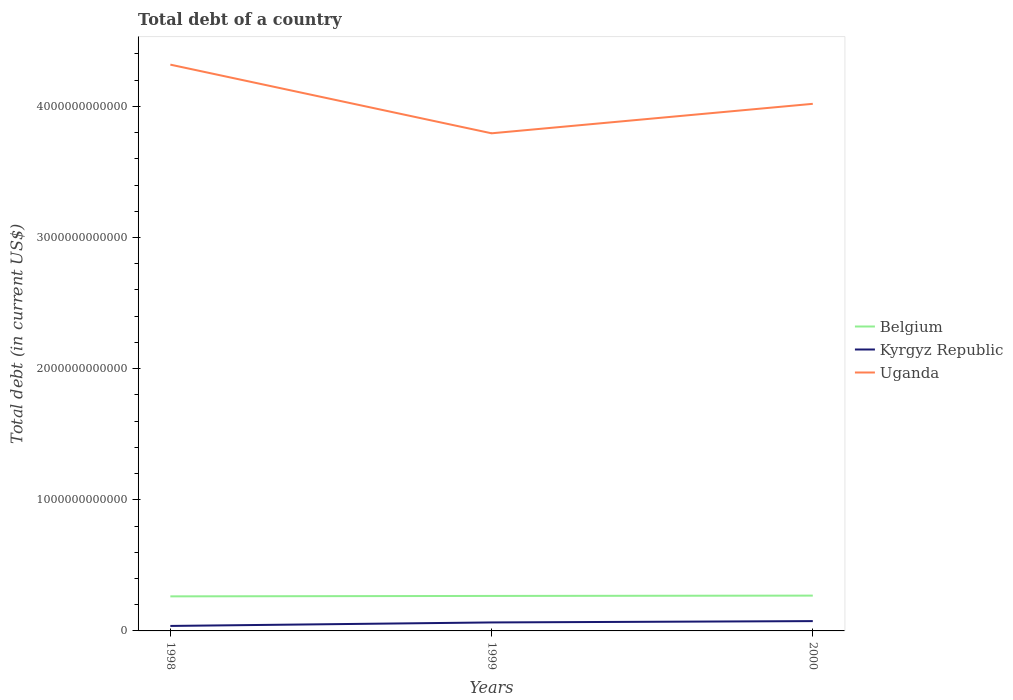How many different coloured lines are there?
Provide a succinct answer. 3. Does the line corresponding to Uganda intersect with the line corresponding to Belgium?
Your response must be concise. No. Across all years, what is the maximum debt in Kyrgyz Republic?
Offer a terse response. 3.80e+1. What is the total debt in Belgium in the graph?
Your answer should be compact. -5.65e+09. What is the difference between the highest and the second highest debt in Belgium?
Make the answer very short. 5.65e+09. What is the difference between the highest and the lowest debt in Uganda?
Offer a terse response. 1. Is the debt in Uganda strictly greater than the debt in Belgium over the years?
Your response must be concise. No. How many lines are there?
Make the answer very short. 3. How many years are there in the graph?
Keep it short and to the point. 3. What is the difference between two consecutive major ticks on the Y-axis?
Offer a terse response. 1.00e+12. Are the values on the major ticks of Y-axis written in scientific E-notation?
Offer a very short reply. No. Does the graph contain grids?
Your answer should be very brief. No. Where does the legend appear in the graph?
Your response must be concise. Center right. How are the legend labels stacked?
Make the answer very short. Vertical. What is the title of the graph?
Make the answer very short. Total debt of a country. Does "Israel" appear as one of the legend labels in the graph?
Your response must be concise. No. What is the label or title of the Y-axis?
Your answer should be very brief. Total debt (in current US$). What is the Total debt (in current US$) in Belgium in 1998?
Keep it short and to the point. 2.64e+11. What is the Total debt (in current US$) in Kyrgyz Republic in 1998?
Your answer should be compact. 3.80e+1. What is the Total debt (in current US$) of Uganda in 1998?
Give a very brief answer. 4.32e+12. What is the Total debt (in current US$) of Belgium in 1999?
Offer a very short reply. 2.67e+11. What is the Total debt (in current US$) of Kyrgyz Republic in 1999?
Keep it short and to the point. 6.47e+1. What is the Total debt (in current US$) in Uganda in 1999?
Make the answer very short. 3.79e+12. What is the Total debt (in current US$) in Belgium in 2000?
Offer a very short reply. 2.69e+11. What is the Total debt (in current US$) of Kyrgyz Republic in 2000?
Give a very brief answer. 7.49e+1. What is the Total debt (in current US$) of Uganda in 2000?
Offer a terse response. 4.02e+12. Across all years, what is the maximum Total debt (in current US$) of Belgium?
Offer a terse response. 2.69e+11. Across all years, what is the maximum Total debt (in current US$) of Kyrgyz Republic?
Offer a terse response. 7.49e+1. Across all years, what is the maximum Total debt (in current US$) of Uganda?
Provide a succinct answer. 4.32e+12. Across all years, what is the minimum Total debt (in current US$) of Belgium?
Provide a short and direct response. 2.64e+11. Across all years, what is the minimum Total debt (in current US$) in Kyrgyz Republic?
Provide a short and direct response. 3.80e+1. Across all years, what is the minimum Total debt (in current US$) of Uganda?
Offer a very short reply. 3.79e+12. What is the total Total debt (in current US$) in Belgium in the graph?
Make the answer very short. 8.00e+11. What is the total Total debt (in current US$) of Kyrgyz Republic in the graph?
Give a very brief answer. 1.78e+11. What is the total Total debt (in current US$) in Uganda in the graph?
Provide a succinct answer. 1.21e+13. What is the difference between the Total debt (in current US$) of Belgium in 1998 and that in 1999?
Your answer should be compact. -3.18e+09. What is the difference between the Total debt (in current US$) in Kyrgyz Republic in 1998 and that in 1999?
Your response must be concise. -2.67e+1. What is the difference between the Total debt (in current US$) in Uganda in 1998 and that in 1999?
Your answer should be very brief. 5.24e+11. What is the difference between the Total debt (in current US$) in Belgium in 1998 and that in 2000?
Your response must be concise. -5.65e+09. What is the difference between the Total debt (in current US$) of Kyrgyz Republic in 1998 and that in 2000?
Provide a short and direct response. -3.68e+1. What is the difference between the Total debt (in current US$) of Uganda in 1998 and that in 2000?
Keep it short and to the point. 2.99e+11. What is the difference between the Total debt (in current US$) in Belgium in 1999 and that in 2000?
Provide a succinct answer. -2.48e+09. What is the difference between the Total debt (in current US$) in Kyrgyz Republic in 1999 and that in 2000?
Provide a succinct answer. -1.02e+1. What is the difference between the Total debt (in current US$) of Uganda in 1999 and that in 2000?
Your response must be concise. -2.25e+11. What is the difference between the Total debt (in current US$) of Belgium in 1998 and the Total debt (in current US$) of Kyrgyz Republic in 1999?
Your answer should be very brief. 1.99e+11. What is the difference between the Total debt (in current US$) in Belgium in 1998 and the Total debt (in current US$) in Uganda in 1999?
Provide a short and direct response. -3.53e+12. What is the difference between the Total debt (in current US$) in Kyrgyz Republic in 1998 and the Total debt (in current US$) in Uganda in 1999?
Provide a short and direct response. -3.76e+12. What is the difference between the Total debt (in current US$) in Belgium in 1998 and the Total debt (in current US$) in Kyrgyz Republic in 2000?
Ensure brevity in your answer.  1.89e+11. What is the difference between the Total debt (in current US$) of Belgium in 1998 and the Total debt (in current US$) of Uganda in 2000?
Offer a terse response. -3.76e+12. What is the difference between the Total debt (in current US$) in Kyrgyz Republic in 1998 and the Total debt (in current US$) in Uganda in 2000?
Give a very brief answer. -3.98e+12. What is the difference between the Total debt (in current US$) in Belgium in 1999 and the Total debt (in current US$) in Kyrgyz Republic in 2000?
Give a very brief answer. 1.92e+11. What is the difference between the Total debt (in current US$) of Belgium in 1999 and the Total debt (in current US$) of Uganda in 2000?
Keep it short and to the point. -3.75e+12. What is the difference between the Total debt (in current US$) of Kyrgyz Republic in 1999 and the Total debt (in current US$) of Uganda in 2000?
Your answer should be compact. -3.96e+12. What is the average Total debt (in current US$) of Belgium per year?
Your response must be concise. 2.67e+11. What is the average Total debt (in current US$) in Kyrgyz Republic per year?
Make the answer very short. 5.92e+1. What is the average Total debt (in current US$) in Uganda per year?
Provide a succinct answer. 4.04e+12. In the year 1998, what is the difference between the Total debt (in current US$) in Belgium and Total debt (in current US$) in Kyrgyz Republic?
Offer a very short reply. 2.26e+11. In the year 1998, what is the difference between the Total debt (in current US$) in Belgium and Total debt (in current US$) in Uganda?
Your response must be concise. -4.05e+12. In the year 1998, what is the difference between the Total debt (in current US$) in Kyrgyz Republic and Total debt (in current US$) in Uganda?
Provide a succinct answer. -4.28e+12. In the year 1999, what is the difference between the Total debt (in current US$) in Belgium and Total debt (in current US$) in Kyrgyz Republic?
Ensure brevity in your answer.  2.02e+11. In the year 1999, what is the difference between the Total debt (in current US$) of Belgium and Total debt (in current US$) of Uganda?
Offer a terse response. -3.53e+12. In the year 1999, what is the difference between the Total debt (in current US$) in Kyrgyz Republic and Total debt (in current US$) in Uganda?
Provide a short and direct response. -3.73e+12. In the year 2000, what is the difference between the Total debt (in current US$) in Belgium and Total debt (in current US$) in Kyrgyz Republic?
Your response must be concise. 1.94e+11. In the year 2000, what is the difference between the Total debt (in current US$) of Belgium and Total debt (in current US$) of Uganda?
Provide a short and direct response. -3.75e+12. In the year 2000, what is the difference between the Total debt (in current US$) of Kyrgyz Republic and Total debt (in current US$) of Uganda?
Your answer should be compact. -3.94e+12. What is the ratio of the Total debt (in current US$) in Belgium in 1998 to that in 1999?
Keep it short and to the point. 0.99. What is the ratio of the Total debt (in current US$) in Kyrgyz Republic in 1998 to that in 1999?
Your answer should be very brief. 0.59. What is the ratio of the Total debt (in current US$) of Uganda in 1998 to that in 1999?
Your response must be concise. 1.14. What is the ratio of the Total debt (in current US$) in Belgium in 1998 to that in 2000?
Give a very brief answer. 0.98. What is the ratio of the Total debt (in current US$) in Kyrgyz Republic in 1998 to that in 2000?
Make the answer very short. 0.51. What is the ratio of the Total debt (in current US$) of Uganda in 1998 to that in 2000?
Ensure brevity in your answer.  1.07. What is the ratio of the Total debt (in current US$) of Belgium in 1999 to that in 2000?
Your answer should be very brief. 0.99. What is the ratio of the Total debt (in current US$) in Kyrgyz Republic in 1999 to that in 2000?
Provide a short and direct response. 0.86. What is the ratio of the Total debt (in current US$) in Uganda in 1999 to that in 2000?
Keep it short and to the point. 0.94. What is the difference between the highest and the second highest Total debt (in current US$) of Belgium?
Provide a short and direct response. 2.48e+09. What is the difference between the highest and the second highest Total debt (in current US$) in Kyrgyz Republic?
Offer a terse response. 1.02e+1. What is the difference between the highest and the second highest Total debt (in current US$) in Uganda?
Give a very brief answer. 2.99e+11. What is the difference between the highest and the lowest Total debt (in current US$) in Belgium?
Ensure brevity in your answer.  5.65e+09. What is the difference between the highest and the lowest Total debt (in current US$) of Kyrgyz Republic?
Your answer should be compact. 3.68e+1. What is the difference between the highest and the lowest Total debt (in current US$) of Uganda?
Give a very brief answer. 5.24e+11. 